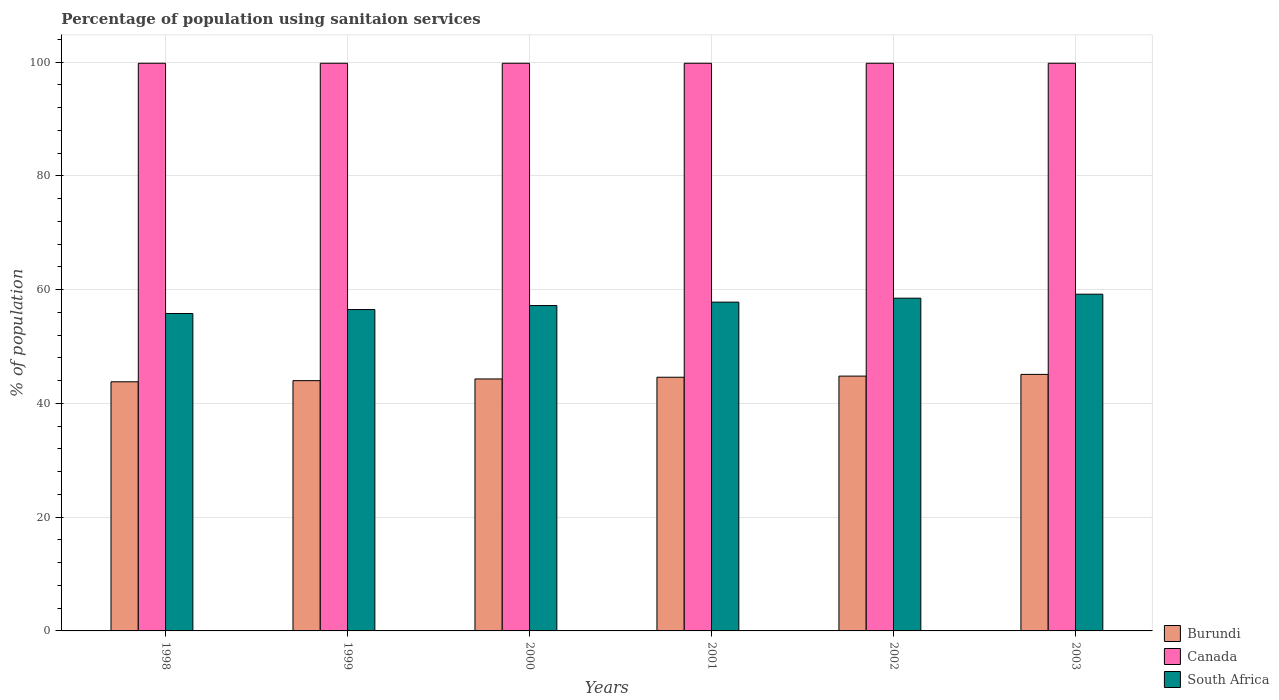How many groups of bars are there?
Make the answer very short. 6. Are the number of bars per tick equal to the number of legend labels?
Make the answer very short. Yes. How many bars are there on the 3rd tick from the right?
Keep it short and to the point. 3. What is the label of the 2nd group of bars from the left?
Give a very brief answer. 1999. In how many cases, is the number of bars for a given year not equal to the number of legend labels?
Offer a very short reply. 0. What is the percentage of population using sanitaion services in Canada in 1999?
Give a very brief answer. 99.8. Across all years, what is the maximum percentage of population using sanitaion services in Canada?
Provide a short and direct response. 99.8. Across all years, what is the minimum percentage of population using sanitaion services in South Africa?
Give a very brief answer. 55.8. In which year was the percentage of population using sanitaion services in Canada minimum?
Your response must be concise. 1998. What is the total percentage of population using sanitaion services in Burundi in the graph?
Provide a short and direct response. 266.6. What is the difference between the percentage of population using sanitaion services in Canada in 2003 and the percentage of population using sanitaion services in Burundi in 2001?
Provide a short and direct response. 55.2. What is the average percentage of population using sanitaion services in South Africa per year?
Make the answer very short. 57.5. In the year 2003, what is the difference between the percentage of population using sanitaion services in South Africa and percentage of population using sanitaion services in Canada?
Ensure brevity in your answer.  -40.6. What is the ratio of the percentage of population using sanitaion services in South Africa in 1998 to that in 2000?
Your answer should be very brief. 0.98. Is the difference between the percentage of population using sanitaion services in South Africa in 2001 and 2002 greater than the difference between the percentage of population using sanitaion services in Canada in 2001 and 2002?
Provide a short and direct response. No. What is the difference between the highest and the second highest percentage of population using sanitaion services in Burundi?
Make the answer very short. 0.3. What is the difference between the highest and the lowest percentage of population using sanitaion services in Burundi?
Ensure brevity in your answer.  1.3. What does the 3rd bar from the left in 2003 represents?
Ensure brevity in your answer.  South Africa. What does the 3rd bar from the right in 1998 represents?
Provide a short and direct response. Burundi. Is it the case that in every year, the sum of the percentage of population using sanitaion services in Canada and percentage of population using sanitaion services in South Africa is greater than the percentage of population using sanitaion services in Burundi?
Your response must be concise. Yes. How many bars are there?
Ensure brevity in your answer.  18. How many years are there in the graph?
Provide a succinct answer. 6. Are the values on the major ticks of Y-axis written in scientific E-notation?
Your response must be concise. No. Does the graph contain any zero values?
Offer a terse response. No. What is the title of the graph?
Offer a very short reply. Percentage of population using sanitaion services. What is the label or title of the Y-axis?
Provide a succinct answer. % of population. What is the % of population in Burundi in 1998?
Ensure brevity in your answer.  43.8. What is the % of population in Canada in 1998?
Offer a terse response. 99.8. What is the % of population in South Africa in 1998?
Your answer should be compact. 55.8. What is the % of population of Burundi in 1999?
Offer a very short reply. 44. What is the % of population in Canada in 1999?
Provide a short and direct response. 99.8. What is the % of population in South Africa in 1999?
Provide a short and direct response. 56.5. What is the % of population in Burundi in 2000?
Make the answer very short. 44.3. What is the % of population in Canada in 2000?
Provide a succinct answer. 99.8. What is the % of population in South Africa in 2000?
Your answer should be compact. 57.2. What is the % of population of Burundi in 2001?
Your answer should be very brief. 44.6. What is the % of population in Canada in 2001?
Your response must be concise. 99.8. What is the % of population in South Africa in 2001?
Give a very brief answer. 57.8. What is the % of population in Burundi in 2002?
Give a very brief answer. 44.8. What is the % of population in Canada in 2002?
Your answer should be very brief. 99.8. What is the % of population of South Africa in 2002?
Your answer should be compact. 58.5. What is the % of population in Burundi in 2003?
Ensure brevity in your answer.  45.1. What is the % of population in Canada in 2003?
Your answer should be compact. 99.8. What is the % of population in South Africa in 2003?
Keep it short and to the point. 59.2. Across all years, what is the maximum % of population in Burundi?
Make the answer very short. 45.1. Across all years, what is the maximum % of population of Canada?
Give a very brief answer. 99.8. Across all years, what is the maximum % of population in South Africa?
Keep it short and to the point. 59.2. Across all years, what is the minimum % of population in Burundi?
Provide a short and direct response. 43.8. Across all years, what is the minimum % of population of Canada?
Keep it short and to the point. 99.8. Across all years, what is the minimum % of population of South Africa?
Give a very brief answer. 55.8. What is the total % of population in Burundi in the graph?
Give a very brief answer. 266.6. What is the total % of population of Canada in the graph?
Provide a short and direct response. 598.8. What is the total % of population of South Africa in the graph?
Your answer should be compact. 345. What is the difference between the % of population of Burundi in 1998 and that in 1999?
Provide a succinct answer. -0.2. What is the difference between the % of population in Canada in 1998 and that in 1999?
Your answer should be very brief. 0. What is the difference between the % of population of South Africa in 1998 and that in 1999?
Your response must be concise. -0.7. What is the difference between the % of population of Burundi in 1998 and that in 2000?
Offer a terse response. -0.5. What is the difference between the % of population of Canada in 1998 and that in 2000?
Your answer should be compact. 0. What is the difference between the % of population in South Africa in 1998 and that in 2000?
Keep it short and to the point. -1.4. What is the difference between the % of population in Canada in 1998 and that in 2001?
Offer a terse response. 0. What is the difference between the % of population of South Africa in 1998 and that in 2001?
Give a very brief answer. -2. What is the difference between the % of population of Burundi in 1998 and that in 2002?
Your answer should be very brief. -1. What is the difference between the % of population in South Africa in 1998 and that in 2002?
Make the answer very short. -2.7. What is the difference between the % of population in Burundi in 1998 and that in 2003?
Your response must be concise. -1.3. What is the difference between the % of population of South Africa in 1998 and that in 2003?
Offer a very short reply. -3.4. What is the difference between the % of population in Burundi in 1999 and that in 2000?
Give a very brief answer. -0.3. What is the difference between the % of population of South Africa in 1999 and that in 2000?
Ensure brevity in your answer.  -0.7. What is the difference between the % of population of Burundi in 1999 and that in 2002?
Your answer should be very brief. -0.8. What is the difference between the % of population of South Africa in 1999 and that in 2002?
Your answer should be compact. -2. What is the difference between the % of population of South Africa in 2000 and that in 2001?
Your answer should be very brief. -0.6. What is the difference between the % of population in Burundi in 2000 and that in 2002?
Your answer should be very brief. -0.5. What is the difference between the % of population of South Africa in 2000 and that in 2002?
Your answer should be very brief. -1.3. What is the difference between the % of population in Burundi in 2000 and that in 2003?
Provide a short and direct response. -0.8. What is the difference between the % of population of Burundi in 2001 and that in 2002?
Make the answer very short. -0.2. What is the difference between the % of population of Canada in 2001 and that in 2002?
Your answer should be very brief. 0. What is the difference between the % of population in Burundi in 2001 and that in 2003?
Your answer should be very brief. -0.5. What is the difference between the % of population in Canada in 2001 and that in 2003?
Keep it short and to the point. 0. What is the difference between the % of population of South Africa in 2001 and that in 2003?
Your answer should be compact. -1.4. What is the difference between the % of population in Canada in 2002 and that in 2003?
Provide a succinct answer. 0. What is the difference between the % of population in Burundi in 1998 and the % of population in Canada in 1999?
Give a very brief answer. -56. What is the difference between the % of population in Burundi in 1998 and the % of population in South Africa in 1999?
Ensure brevity in your answer.  -12.7. What is the difference between the % of population in Canada in 1998 and the % of population in South Africa in 1999?
Offer a terse response. 43.3. What is the difference between the % of population of Burundi in 1998 and the % of population of Canada in 2000?
Your answer should be very brief. -56. What is the difference between the % of population of Burundi in 1998 and the % of population of South Africa in 2000?
Your response must be concise. -13.4. What is the difference between the % of population of Canada in 1998 and the % of population of South Africa in 2000?
Your response must be concise. 42.6. What is the difference between the % of population in Burundi in 1998 and the % of population in Canada in 2001?
Provide a short and direct response. -56. What is the difference between the % of population in Burundi in 1998 and the % of population in Canada in 2002?
Keep it short and to the point. -56. What is the difference between the % of population in Burundi in 1998 and the % of population in South Africa in 2002?
Offer a very short reply. -14.7. What is the difference between the % of population of Canada in 1998 and the % of population of South Africa in 2002?
Your answer should be compact. 41.3. What is the difference between the % of population in Burundi in 1998 and the % of population in Canada in 2003?
Offer a terse response. -56. What is the difference between the % of population of Burundi in 1998 and the % of population of South Africa in 2003?
Your answer should be compact. -15.4. What is the difference between the % of population of Canada in 1998 and the % of population of South Africa in 2003?
Offer a terse response. 40.6. What is the difference between the % of population in Burundi in 1999 and the % of population in Canada in 2000?
Your answer should be compact. -55.8. What is the difference between the % of population in Burundi in 1999 and the % of population in South Africa in 2000?
Offer a terse response. -13.2. What is the difference between the % of population of Canada in 1999 and the % of population of South Africa in 2000?
Provide a short and direct response. 42.6. What is the difference between the % of population of Burundi in 1999 and the % of population of Canada in 2001?
Provide a succinct answer. -55.8. What is the difference between the % of population of Burundi in 1999 and the % of population of South Africa in 2001?
Provide a short and direct response. -13.8. What is the difference between the % of population of Burundi in 1999 and the % of population of Canada in 2002?
Your answer should be compact. -55.8. What is the difference between the % of population of Canada in 1999 and the % of population of South Africa in 2002?
Your response must be concise. 41.3. What is the difference between the % of population in Burundi in 1999 and the % of population in Canada in 2003?
Ensure brevity in your answer.  -55.8. What is the difference between the % of population in Burundi in 1999 and the % of population in South Africa in 2003?
Your response must be concise. -15.2. What is the difference between the % of population of Canada in 1999 and the % of population of South Africa in 2003?
Give a very brief answer. 40.6. What is the difference between the % of population in Burundi in 2000 and the % of population in Canada in 2001?
Give a very brief answer. -55.5. What is the difference between the % of population of Canada in 2000 and the % of population of South Africa in 2001?
Give a very brief answer. 42. What is the difference between the % of population of Burundi in 2000 and the % of population of Canada in 2002?
Your answer should be very brief. -55.5. What is the difference between the % of population in Burundi in 2000 and the % of population in South Africa in 2002?
Provide a short and direct response. -14.2. What is the difference between the % of population of Canada in 2000 and the % of population of South Africa in 2002?
Keep it short and to the point. 41.3. What is the difference between the % of population in Burundi in 2000 and the % of population in Canada in 2003?
Keep it short and to the point. -55.5. What is the difference between the % of population in Burundi in 2000 and the % of population in South Africa in 2003?
Your response must be concise. -14.9. What is the difference between the % of population in Canada in 2000 and the % of population in South Africa in 2003?
Make the answer very short. 40.6. What is the difference between the % of population in Burundi in 2001 and the % of population in Canada in 2002?
Your answer should be very brief. -55.2. What is the difference between the % of population of Burundi in 2001 and the % of population of South Africa in 2002?
Give a very brief answer. -13.9. What is the difference between the % of population of Canada in 2001 and the % of population of South Africa in 2002?
Give a very brief answer. 41.3. What is the difference between the % of population in Burundi in 2001 and the % of population in Canada in 2003?
Offer a very short reply. -55.2. What is the difference between the % of population in Burundi in 2001 and the % of population in South Africa in 2003?
Your answer should be compact. -14.6. What is the difference between the % of population of Canada in 2001 and the % of population of South Africa in 2003?
Provide a short and direct response. 40.6. What is the difference between the % of population of Burundi in 2002 and the % of population of Canada in 2003?
Your answer should be compact. -55. What is the difference between the % of population in Burundi in 2002 and the % of population in South Africa in 2003?
Provide a succinct answer. -14.4. What is the difference between the % of population of Canada in 2002 and the % of population of South Africa in 2003?
Your answer should be very brief. 40.6. What is the average % of population of Burundi per year?
Your response must be concise. 44.43. What is the average % of population in Canada per year?
Your response must be concise. 99.8. What is the average % of population of South Africa per year?
Give a very brief answer. 57.5. In the year 1998, what is the difference between the % of population in Burundi and % of population in Canada?
Keep it short and to the point. -56. In the year 1998, what is the difference between the % of population of Burundi and % of population of South Africa?
Keep it short and to the point. -12. In the year 1998, what is the difference between the % of population of Canada and % of population of South Africa?
Provide a short and direct response. 44. In the year 1999, what is the difference between the % of population in Burundi and % of population in Canada?
Your answer should be very brief. -55.8. In the year 1999, what is the difference between the % of population in Burundi and % of population in South Africa?
Your answer should be very brief. -12.5. In the year 1999, what is the difference between the % of population of Canada and % of population of South Africa?
Make the answer very short. 43.3. In the year 2000, what is the difference between the % of population of Burundi and % of population of Canada?
Provide a short and direct response. -55.5. In the year 2000, what is the difference between the % of population in Burundi and % of population in South Africa?
Your answer should be compact. -12.9. In the year 2000, what is the difference between the % of population of Canada and % of population of South Africa?
Keep it short and to the point. 42.6. In the year 2001, what is the difference between the % of population in Burundi and % of population in Canada?
Your answer should be very brief. -55.2. In the year 2002, what is the difference between the % of population in Burundi and % of population in Canada?
Ensure brevity in your answer.  -55. In the year 2002, what is the difference between the % of population in Burundi and % of population in South Africa?
Provide a short and direct response. -13.7. In the year 2002, what is the difference between the % of population in Canada and % of population in South Africa?
Make the answer very short. 41.3. In the year 2003, what is the difference between the % of population in Burundi and % of population in Canada?
Make the answer very short. -54.7. In the year 2003, what is the difference between the % of population of Burundi and % of population of South Africa?
Your response must be concise. -14.1. In the year 2003, what is the difference between the % of population in Canada and % of population in South Africa?
Your response must be concise. 40.6. What is the ratio of the % of population of Canada in 1998 to that in 1999?
Offer a terse response. 1. What is the ratio of the % of population of South Africa in 1998 to that in 1999?
Offer a terse response. 0.99. What is the ratio of the % of population of Burundi in 1998 to that in 2000?
Offer a terse response. 0.99. What is the ratio of the % of population in Canada in 1998 to that in 2000?
Make the answer very short. 1. What is the ratio of the % of population of South Africa in 1998 to that in 2000?
Your response must be concise. 0.98. What is the ratio of the % of population of Burundi in 1998 to that in 2001?
Ensure brevity in your answer.  0.98. What is the ratio of the % of population of South Africa in 1998 to that in 2001?
Ensure brevity in your answer.  0.97. What is the ratio of the % of population in Burundi in 1998 to that in 2002?
Offer a terse response. 0.98. What is the ratio of the % of population in South Africa in 1998 to that in 2002?
Your answer should be very brief. 0.95. What is the ratio of the % of population of Burundi in 1998 to that in 2003?
Your answer should be compact. 0.97. What is the ratio of the % of population in Canada in 1998 to that in 2003?
Provide a succinct answer. 1. What is the ratio of the % of population in South Africa in 1998 to that in 2003?
Make the answer very short. 0.94. What is the ratio of the % of population of Canada in 1999 to that in 2000?
Provide a succinct answer. 1. What is the ratio of the % of population of Burundi in 1999 to that in 2001?
Your answer should be compact. 0.99. What is the ratio of the % of population in South Africa in 1999 to that in 2001?
Ensure brevity in your answer.  0.98. What is the ratio of the % of population in Burundi in 1999 to that in 2002?
Offer a terse response. 0.98. What is the ratio of the % of population in South Africa in 1999 to that in 2002?
Your answer should be compact. 0.97. What is the ratio of the % of population of Burundi in 1999 to that in 2003?
Give a very brief answer. 0.98. What is the ratio of the % of population in South Africa in 1999 to that in 2003?
Your response must be concise. 0.95. What is the ratio of the % of population of Canada in 2000 to that in 2001?
Offer a very short reply. 1. What is the ratio of the % of population of Burundi in 2000 to that in 2002?
Your answer should be compact. 0.99. What is the ratio of the % of population of South Africa in 2000 to that in 2002?
Your response must be concise. 0.98. What is the ratio of the % of population in Burundi in 2000 to that in 2003?
Offer a very short reply. 0.98. What is the ratio of the % of population in South Africa in 2000 to that in 2003?
Give a very brief answer. 0.97. What is the ratio of the % of population in Burundi in 2001 to that in 2002?
Ensure brevity in your answer.  1. What is the ratio of the % of population of South Africa in 2001 to that in 2002?
Provide a short and direct response. 0.99. What is the ratio of the % of population of Burundi in 2001 to that in 2003?
Make the answer very short. 0.99. What is the ratio of the % of population of Canada in 2001 to that in 2003?
Provide a succinct answer. 1. What is the ratio of the % of population in South Africa in 2001 to that in 2003?
Your answer should be very brief. 0.98. What is the ratio of the % of population of Canada in 2002 to that in 2003?
Ensure brevity in your answer.  1. What is the ratio of the % of population in South Africa in 2002 to that in 2003?
Your answer should be very brief. 0.99. What is the difference between the highest and the second highest % of population in Burundi?
Your answer should be compact. 0.3. What is the difference between the highest and the second highest % of population in Canada?
Ensure brevity in your answer.  0. What is the difference between the highest and the second highest % of population in South Africa?
Offer a very short reply. 0.7. What is the difference between the highest and the lowest % of population in South Africa?
Your answer should be very brief. 3.4. 